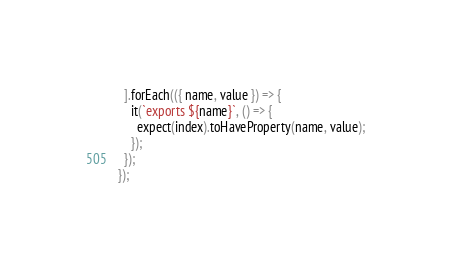Convert code to text. <code><loc_0><loc_0><loc_500><loc_500><_JavaScript_>  ].forEach(({ name, value }) => {
    it(`exports ${name}`, () => {
      expect(index).toHaveProperty(name, value);
    });
  });
});
</code> 